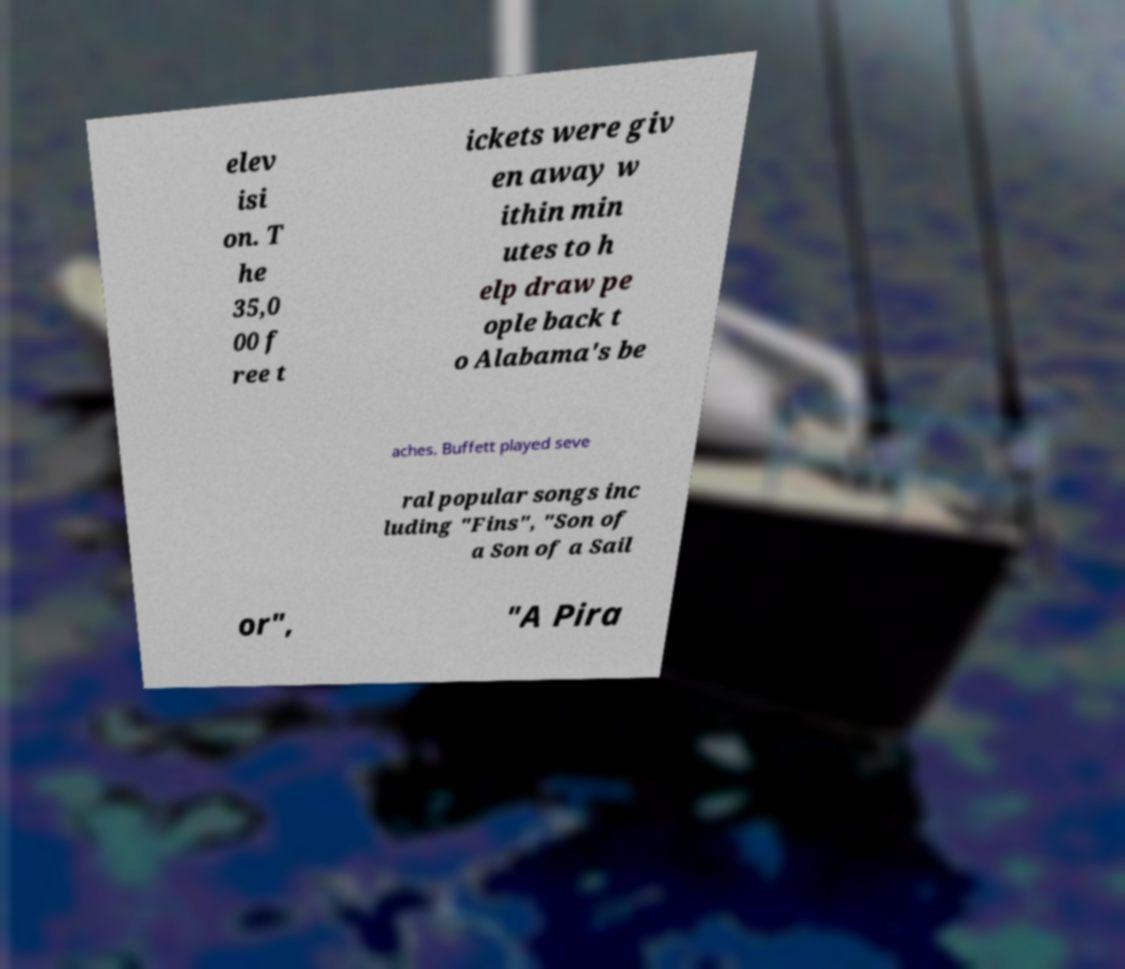For documentation purposes, I need the text within this image transcribed. Could you provide that? elev isi on. T he 35,0 00 f ree t ickets were giv en away w ithin min utes to h elp draw pe ople back t o Alabama's be aches. Buffett played seve ral popular songs inc luding "Fins", "Son of a Son of a Sail or", "A Pira 